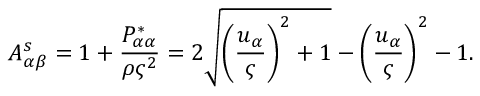<formula> <loc_0><loc_0><loc_500><loc_500>A _ { \alpha \beta } ^ { s } = 1 + \frac { P _ { \alpha \alpha } ^ { * } } { \rho \varsigma ^ { 2 } } = 2 \sqrt { { \left ( \frac { u _ { \alpha } } { \varsigma } \right ) } ^ { 2 } + 1 } - { \left ( \frac { u _ { \alpha } } { \varsigma } \right ) } ^ { 2 } - 1 .</formula> 